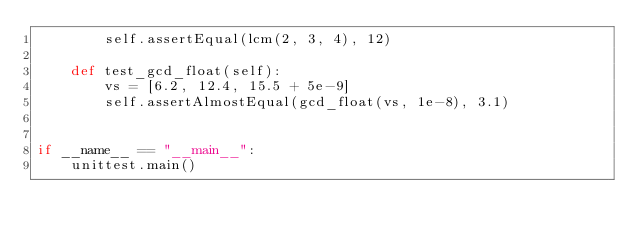<code> <loc_0><loc_0><loc_500><loc_500><_Python_>        self.assertEqual(lcm(2, 3, 4), 12)

    def test_gcd_float(self):
        vs = [6.2, 12.4, 15.5 + 5e-9]
        self.assertAlmostEqual(gcd_float(vs, 1e-8), 3.1)


if __name__ == "__main__":
    unittest.main()
</code> 